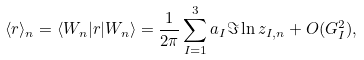<formula> <loc_0><loc_0><loc_500><loc_500>\langle { r } \rangle _ { n } = \langle W _ { n } | { r } | W _ { n } \rangle = \frac { 1 } { 2 \pi } \sum _ { I = 1 } ^ { 3 } { a } _ { I } \Im \ln z _ { I , n } + O ( { G } _ { I } ^ { 2 } ) ,</formula> 